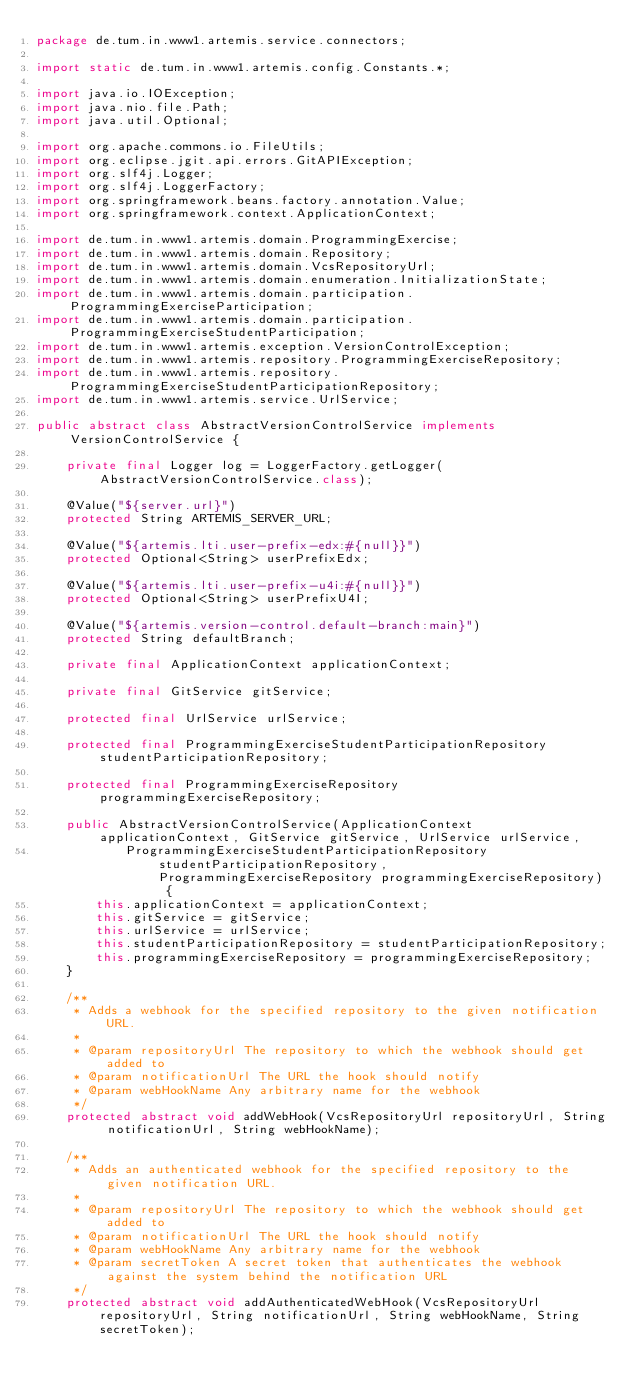<code> <loc_0><loc_0><loc_500><loc_500><_Java_>package de.tum.in.www1.artemis.service.connectors;

import static de.tum.in.www1.artemis.config.Constants.*;

import java.io.IOException;
import java.nio.file.Path;
import java.util.Optional;

import org.apache.commons.io.FileUtils;
import org.eclipse.jgit.api.errors.GitAPIException;
import org.slf4j.Logger;
import org.slf4j.LoggerFactory;
import org.springframework.beans.factory.annotation.Value;
import org.springframework.context.ApplicationContext;

import de.tum.in.www1.artemis.domain.ProgrammingExercise;
import de.tum.in.www1.artemis.domain.Repository;
import de.tum.in.www1.artemis.domain.VcsRepositoryUrl;
import de.tum.in.www1.artemis.domain.enumeration.InitializationState;
import de.tum.in.www1.artemis.domain.participation.ProgrammingExerciseParticipation;
import de.tum.in.www1.artemis.domain.participation.ProgrammingExerciseStudentParticipation;
import de.tum.in.www1.artemis.exception.VersionControlException;
import de.tum.in.www1.artemis.repository.ProgrammingExerciseRepository;
import de.tum.in.www1.artemis.repository.ProgrammingExerciseStudentParticipationRepository;
import de.tum.in.www1.artemis.service.UrlService;

public abstract class AbstractVersionControlService implements VersionControlService {

    private final Logger log = LoggerFactory.getLogger(AbstractVersionControlService.class);

    @Value("${server.url}")
    protected String ARTEMIS_SERVER_URL;

    @Value("${artemis.lti.user-prefix-edx:#{null}}")
    protected Optional<String> userPrefixEdx;

    @Value("${artemis.lti.user-prefix-u4i:#{null}}")
    protected Optional<String> userPrefixU4I;

    @Value("${artemis.version-control.default-branch:main}")
    protected String defaultBranch;

    private final ApplicationContext applicationContext;

    private final GitService gitService;

    protected final UrlService urlService;

    protected final ProgrammingExerciseStudentParticipationRepository studentParticipationRepository;

    protected final ProgrammingExerciseRepository programmingExerciseRepository;

    public AbstractVersionControlService(ApplicationContext applicationContext, GitService gitService, UrlService urlService,
            ProgrammingExerciseStudentParticipationRepository studentParticipationRepository, ProgrammingExerciseRepository programmingExerciseRepository) {
        this.applicationContext = applicationContext;
        this.gitService = gitService;
        this.urlService = urlService;
        this.studentParticipationRepository = studentParticipationRepository;
        this.programmingExerciseRepository = programmingExerciseRepository;
    }

    /**
     * Adds a webhook for the specified repository to the given notification URL.
     *
     * @param repositoryUrl The repository to which the webhook should get added to
     * @param notificationUrl The URL the hook should notify
     * @param webHookName Any arbitrary name for the webhook
     */
    protected abstract void addWebHook(VcsRepositoryUrl repositoryUrl, String notificationUrl, String webHookName);

    /**
     * Adds an authenticated webhook for the specified repository to the given notification URL.
     *
     * @param repositoryUrl The repository to which the webhook should get added to
     * @param notificationUrl The URL the hook should notify
     * @param webHookName Any arbitrary name for the webhook
     * @param secretToken A secret token that authenticates the webhook against the system behind the notification URL
     */
    protected abstract void addAuthenticatedWebHook(VcsRepositoryUrl repositoryUrl, String notificationUrl, String webHookName, String secretToken);
</code> 